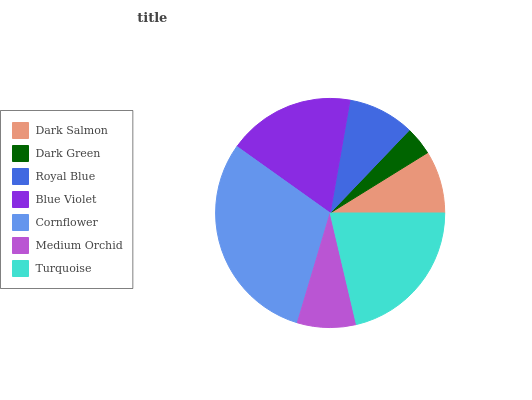Is Dark Green the minimum?
Answer yes or no. Yes. Is Cornflower the maximum?
Answer yes or no. Yes. Is Royal Blue the minimum?
Answer yes or no. No. Is Royal Blue the maximum?
Answer yes or no. No. Is Royal Blue greater than Dark Green?
Answer yes or no. Yes. Is Dark Green less than Royal Blue?
Answer yes or no. Yes. Is Dark Green greater than Royal Blue?
Answer yes or no. No. Is Royal Blue less than Dark Green?
Answer yes or no. No. Is Royal Blue the high median?
Answer yes or no. Yes. Is Royal Blue the low median?
Answer yes or no. Yes. Is Blue Violet the high median?
Answer yes or no. No. Is Turquoise the low median?
Answer yes or no. No. 